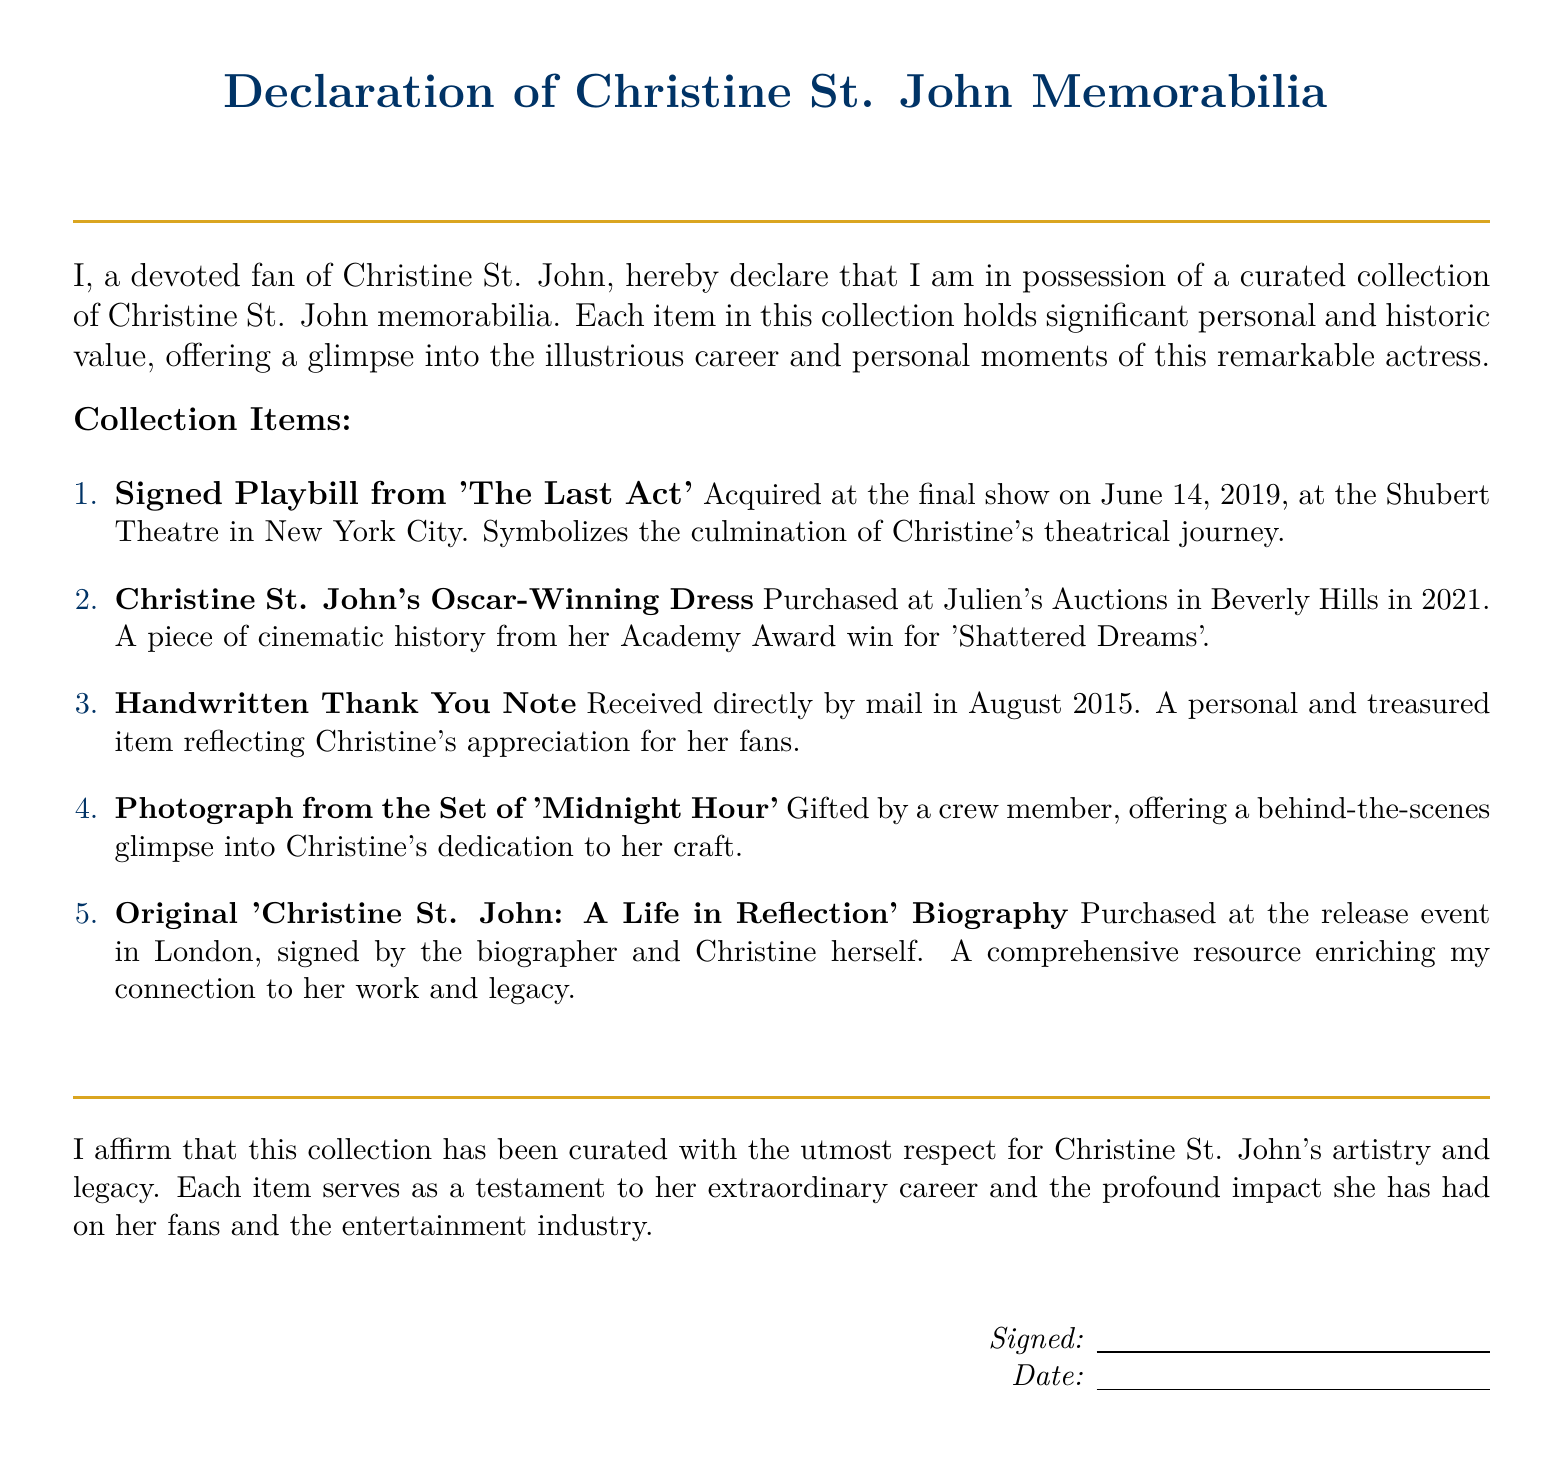What is the title of the collection? The title of the collection is declared as "Declaration of Christine St. John Memorabilia."
Answer: Declaration of Christine St. John Memorabilia When was the signed Playbill acquired? The signed Playbill was acquired at the final show on June 14, 2019.
Answer: June 14, 2019 What item symbolizes Christine's theatrical journey? The signed Playbill from 'The Last Act' symbolizes Christine's theatrical journey.
Answer: Signed Playbill from 'The Last Act' In what year was Christine St. John's Oscar-winning dress purchased? The dress was purchased in 2021 at Julien's Auctions.
Answer: 2021 What personal item reflects Christine's appreciation for her fans? The handwritten thank you note reflects Christine's appreciation for her fans.
Answer: Handwritten Thank You Note Which memorabilia item was gifted by a crew member? The photograph from the set of 'Midnight Hour' was gifted by a crew member.
Answer: Photograph from the Set of 'Midnight Hour' Where was the biography acquired? The biography was purchased at the release event in London.
Answer: release event in London How many items are listed in the collection? There are a total of five items listed in the collection.
Answer: Five What does the collection affirm about Christine St. John? The collection affirms respect for Christine St. John's artistry and legacy.
Answer: respect for Christine St. John's artistry and legacy 